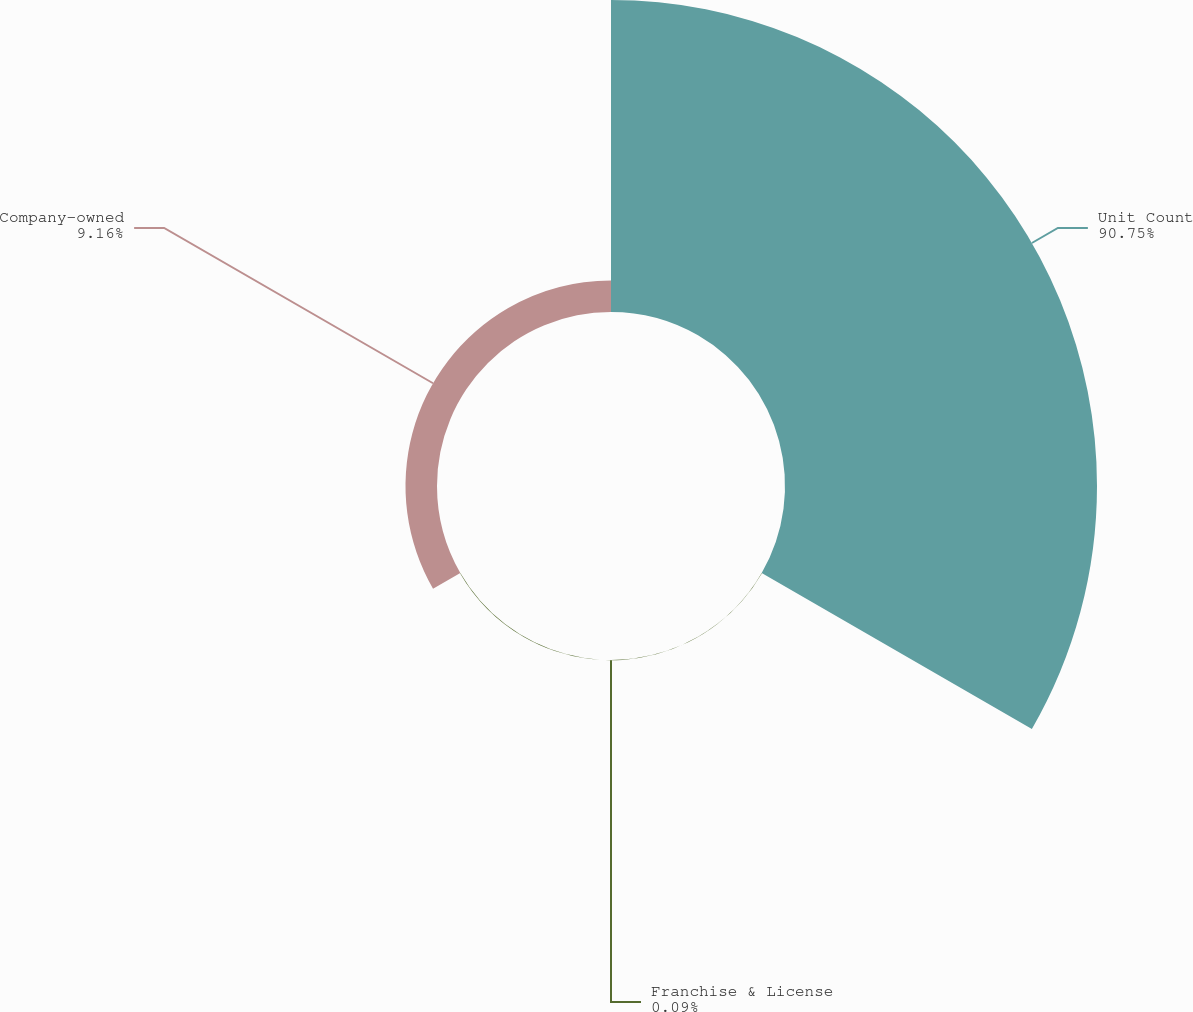<chart> <loc_0><loc_0><loc_500><loc_500><pie_chart><fcel>Unit Count<fcel>Franchise & License<fcel>Company-owned<nl><fcel>90.75%<fcel>0.09%<fcel>9.16%<nl></chart> 